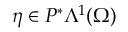Convert formula to latex. <formula><loc_0><loc_0><loc_500><loc_500>\eta \in P ^ { \ast } \Lambda ^ { 1 } ( \Omega )</formula> 